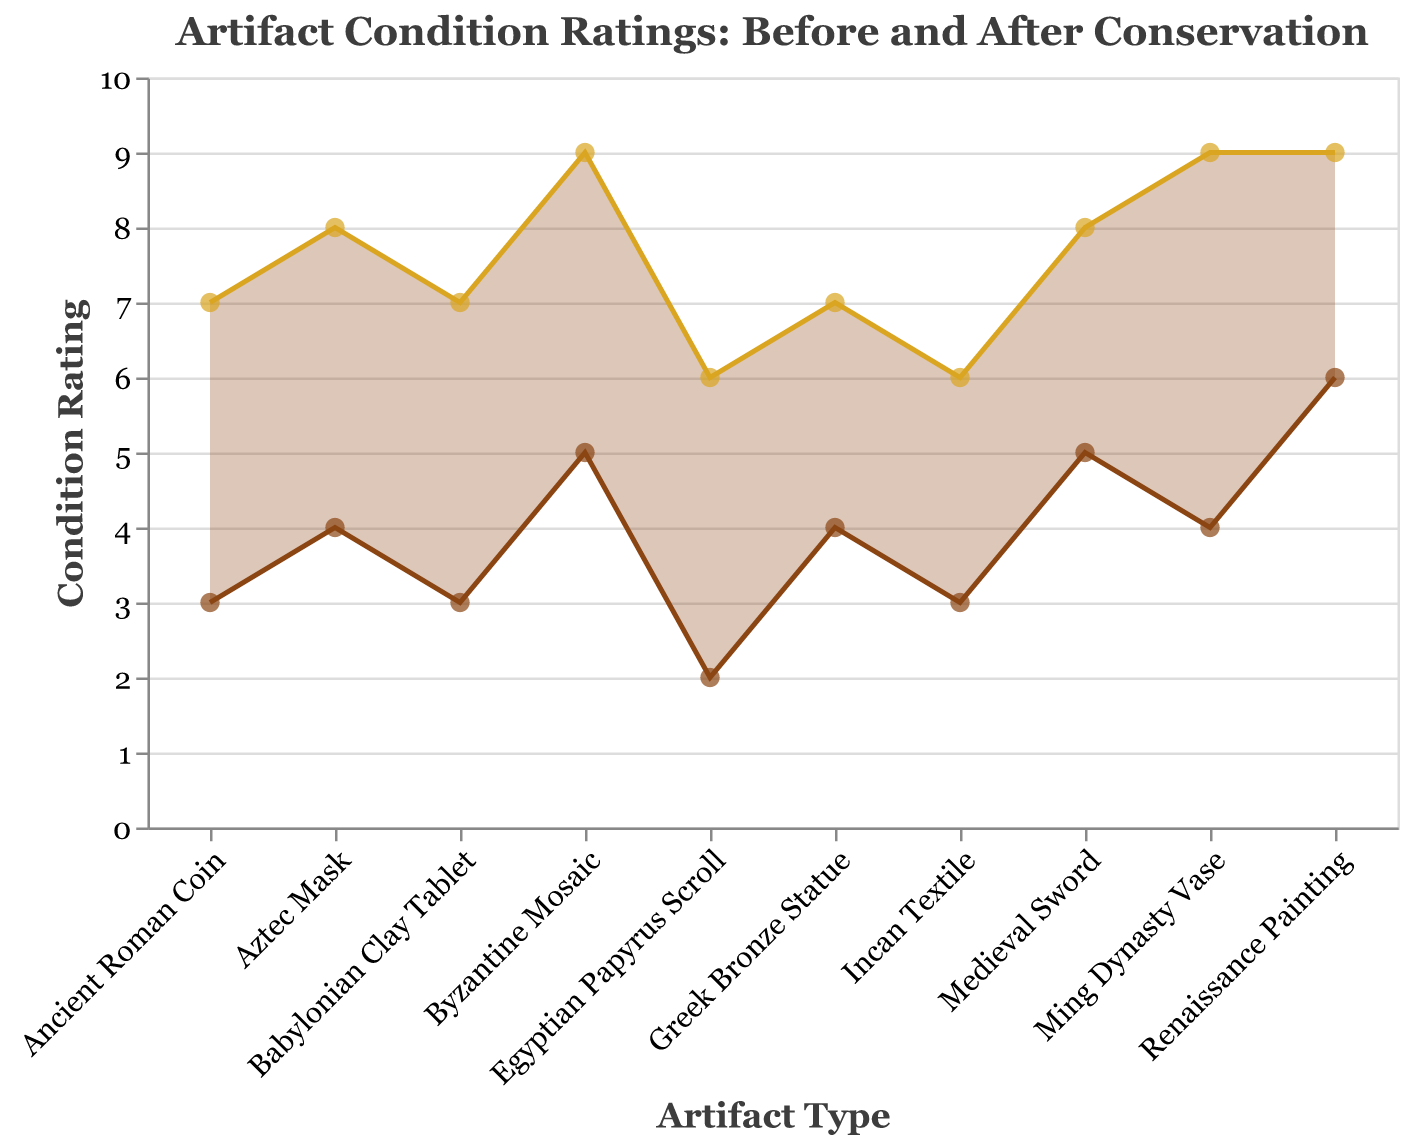What is the title of the figure? The title is located at the top of the figure, and it tells us about the overall theme.
Answer: Artifact Condition Ratings: Before and After Conservation How many artifacts are presented in the figure? Count the number of unique data points plotted on the x-axis, each representing an artifact.
Answer: 10 Which artifact shows the highest condition rating after conservation? Look at the y-values for the "After Conservation" series to find the highest point.
Answer: Ming Dynasty Vase, Renaissance Painting, Byzantine Mosaic What is the condition rating of the Egyptian Papyrus Scroll before and after conservation? Identify the specific points for "Egyptian Papyrus Scroll" in both "Before Conservation" and "After Conservation" series on the graph.
Answer: Before: 2, After: 6 Which artifact improved the most in condition rating after conservation efforts? Subtract the "Before Conservation" ratings from the "After Conservation" ratings for each artifact, then identify the largest difference.
Answer: Ming Dynasty Vase (5 points) Which artifact had the least improvement after conservation? Similar to the previous question, subtract the "Before Conservation" ratings from the "After Conservation" ratings, and find the smallest positive difference.
Answer: Most artifacts have a similar improvement of 3-4 points, except the Egyptian Papyrus Scroll with an improvement of 4 points What is the average condition rating improvement for all artifacts? Calculate the difference between "After Conservation" and "Before Conservation" for each artifact, sum them up, and divide by the number of artifacts.
Answer: (4+5+4+3+3+3+4+4+4+3)/10 = 3.7 Between the Greek Bronze Statue and the Medieval Sword, which had a higher initial condition rating? Compare the y-values for these two artifacts in the "Before Conservation" series to determine which is higher.
Answer: Medieval Sword Which artifacts had the same condition rating improvement after conservation? Identify artifacts with identical differences between their "After Conservation" and "Before Conservation" ratings.
Answer: Ancient Roman Coin, Babylonian Clay Tablet, Incan Textile Is there any artifact that did not reach a condition rating of 6 after conservation? Check the "After Conservation" series to see if any artifact has a y-value less than 6.
Answer: None 